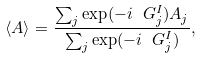Convert formula to latex. <formula><loc_0><loc_0><loc_500><loc_500>\langle A \rangle = \frac { \sum _ { j } \exp ( - i \ G ^ { I } _ { j } ) A _ { j } } { \sum _ { j } \exp ( - i \ G ^ { I } _ { j } ) } ,</formula> 